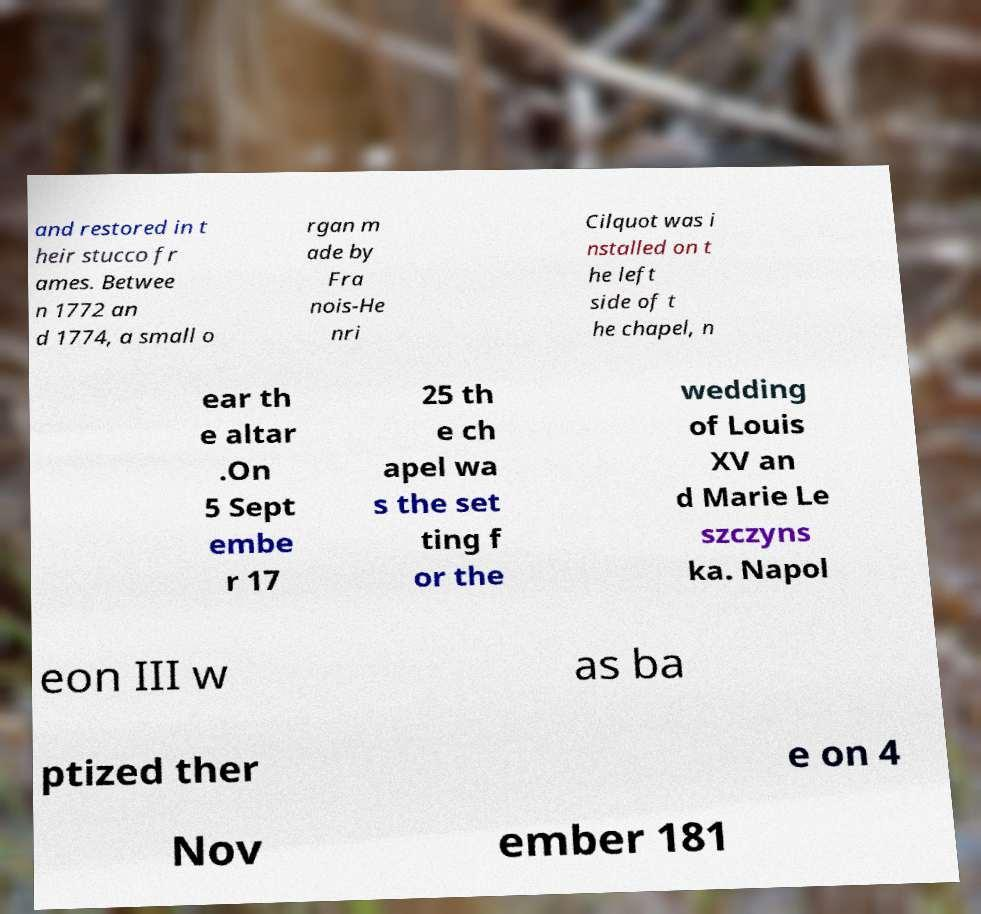There's text embedded in this image that I need extracted. Can you transcribe it verbatim? and restored in t heir stucco fr ames. Betwee n 1772 an d 1774, a small o rgan m ade by Fra nois-He nri Cilquot was i nstalled on t he left side of t he chapel, n ear th e altar .On 5 Sept embe r 17 25 th e ch apel wa s the set ting f or the wedding of Louis XV an d Marie Le szczyns ka. Napol eon III w as ba ptized ther e on 4 Nov ember 181 